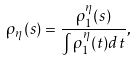Convert formula to latex. <formula><loc_0><loc_0><loc_500><loc_500>\rho _ { \eta } ( s ) = \frac { \rho _ { 1 } ^ { \eta } ( s ) } { \int \rho _ { 1 } ^ { \eta } ( t ) d t } ,</formula> 